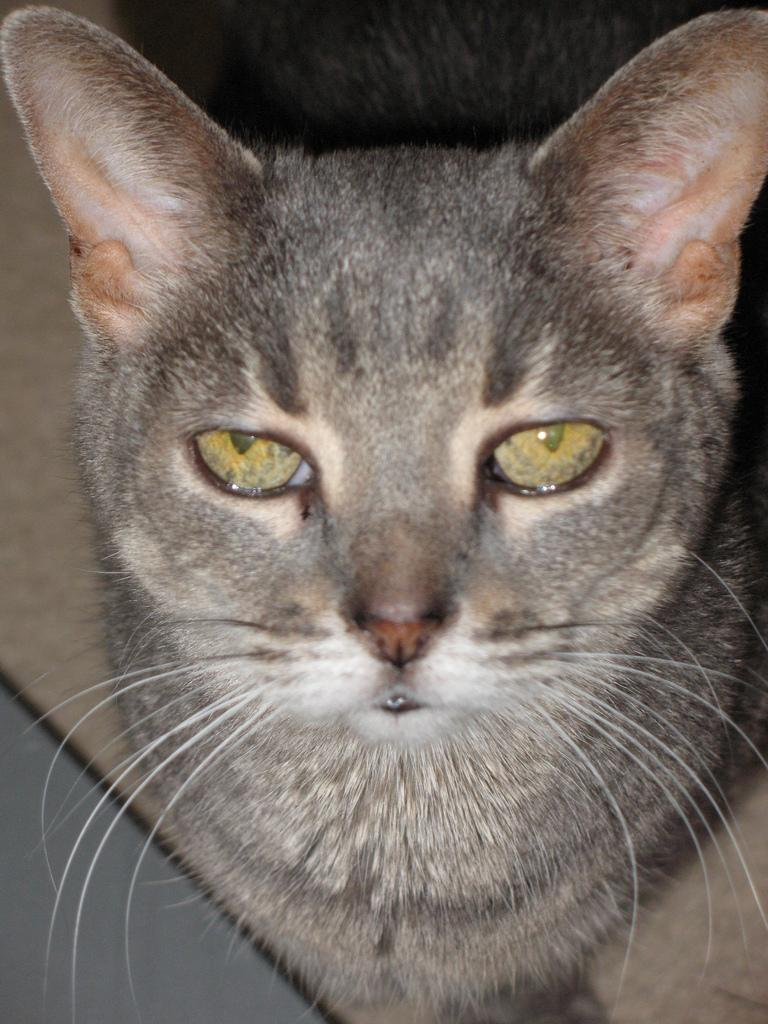What type of animal is in the image? There is a cat in the image. Can you describe the color of the cat? The cat is grey in color. How many elbows does the cat have in the image? Cats do not have elbows; they have front legs and hind legs. 